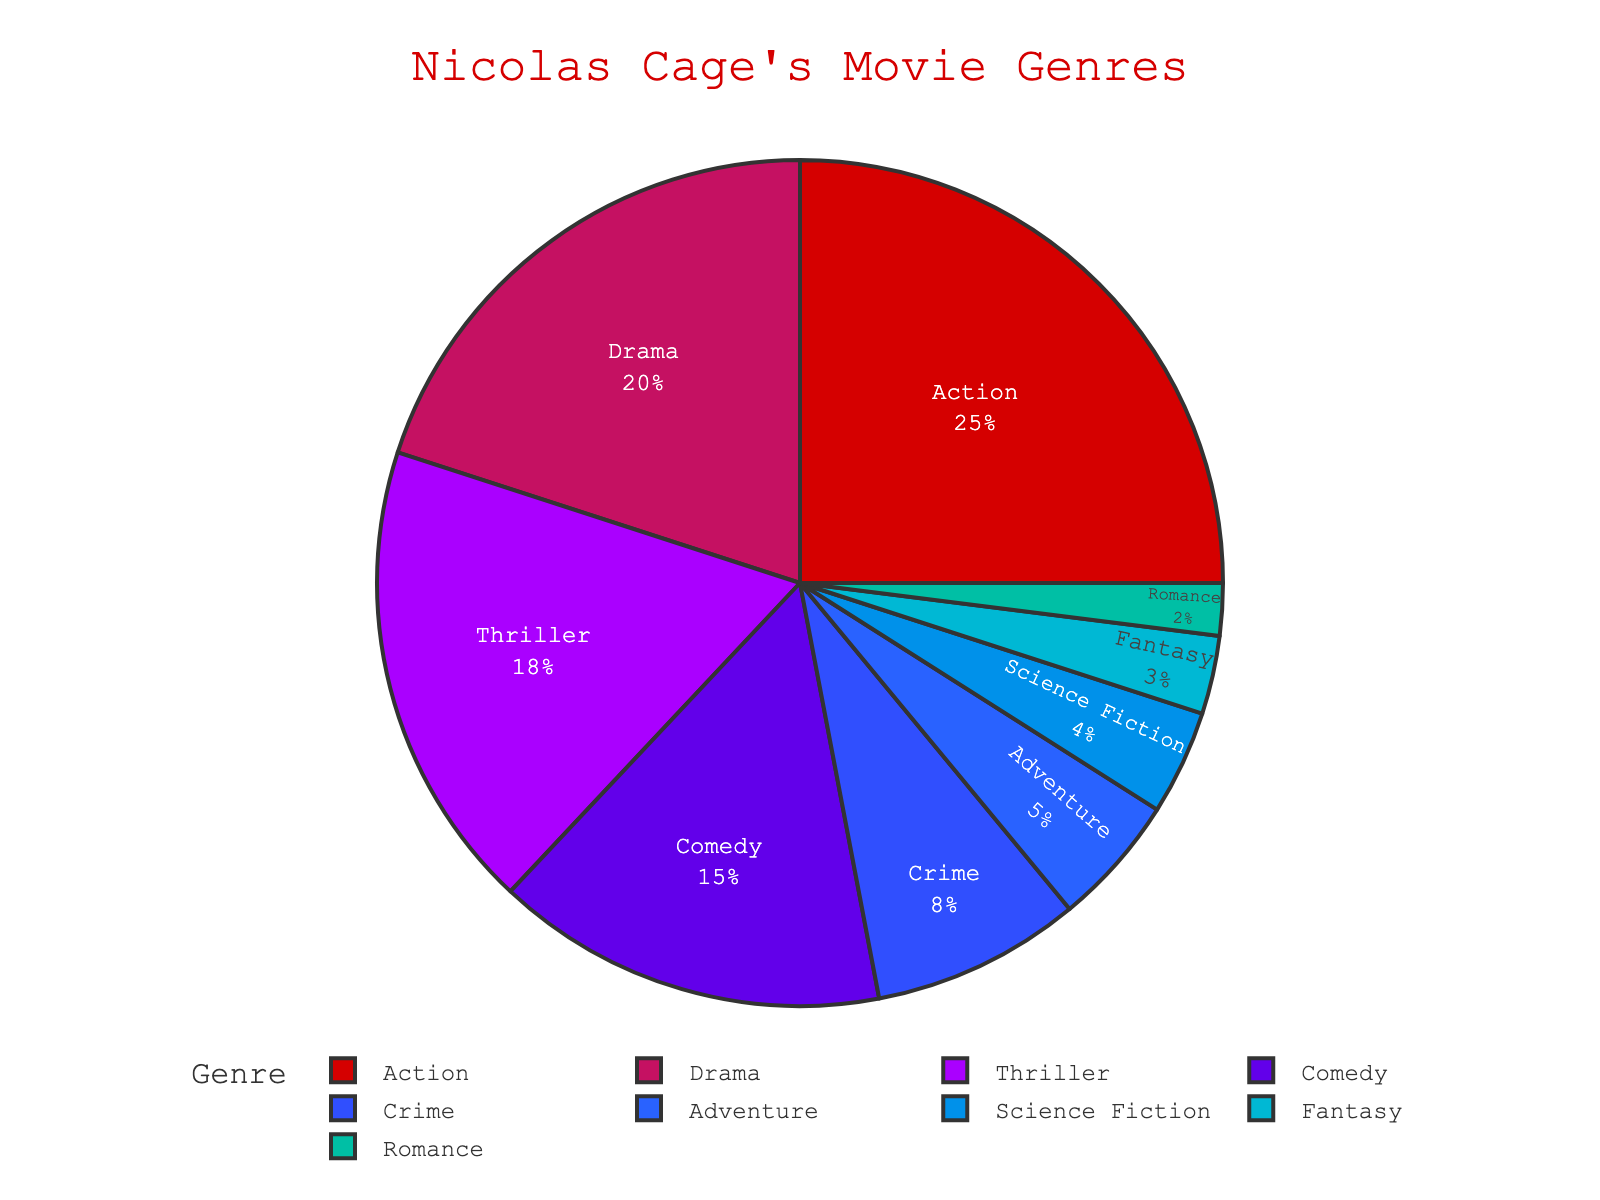What percentage of Nicolas Cage's movies fall under the Action genre? The pie chart indicates the percentage of movies in each genre. According to the chart, the Action genre has a segment labeled with 25%.
Answer: 25% Which genre has the second highest percentage? By observing the pie chart, the Action genre has the highest percentage at 25% followed by the Drama genre, which has a segment labeled with 20%.
Answer: Drama How much larger is the percentage of Action movies compared to Comedy movies? The pie chart shows that Action movies account for 25% while Comedy movies account for 15%. The difference is calculated as 25% - 15%.
Answer: 10% What is the total percentage of movies in the Thriller, Crime, and Romance genres combined? Adding the percentages for Thriller (18%), Crime (8%), and Romance (2%) gives the total. So, 18% + 8% + 2% = 28%.
Answer: 28% Is the percentage of Comedy movies larger than that of Adventure movies? By examining the chart, Comedy movies make up 15% while Adventure movies make up 5%. Therefore, Comedy is larger than Adventure.
Answer: Yes Which genre is represented by the smallest segment in the pie chart? Looking at the pie chart, the Romance genre has the smallest segment with a percentage of 2%.
Answer: Romance How does the percentage of Science Fiction movies compare to that of Fantasy movies? The chart shows Science Fiction at 4% and Fantasy at 3%. Thus, Science Fiction has a slightly larger percentage than Fantasy.
Answer: Science Fiction is larger What is the combined percentage of Action and Drama movies? Adding the percentages of Action (25%) and Drama (20%) results in a total of 45%.
Answer: 45% How much smaller is the percentage of Adventure movies compared to Thriller movies? The pie chart shows Adventure at 5% and Thriller at 18%. The difference is 18% - 5%, which is 13%.
Answer: 13% Can you identify the color representing the Crime genre in the pie chart? Observing the segments, the Crime genre is represented with an orange-like color, which corresponds to its label and segment in the chart.
Answer: Orange-like color 